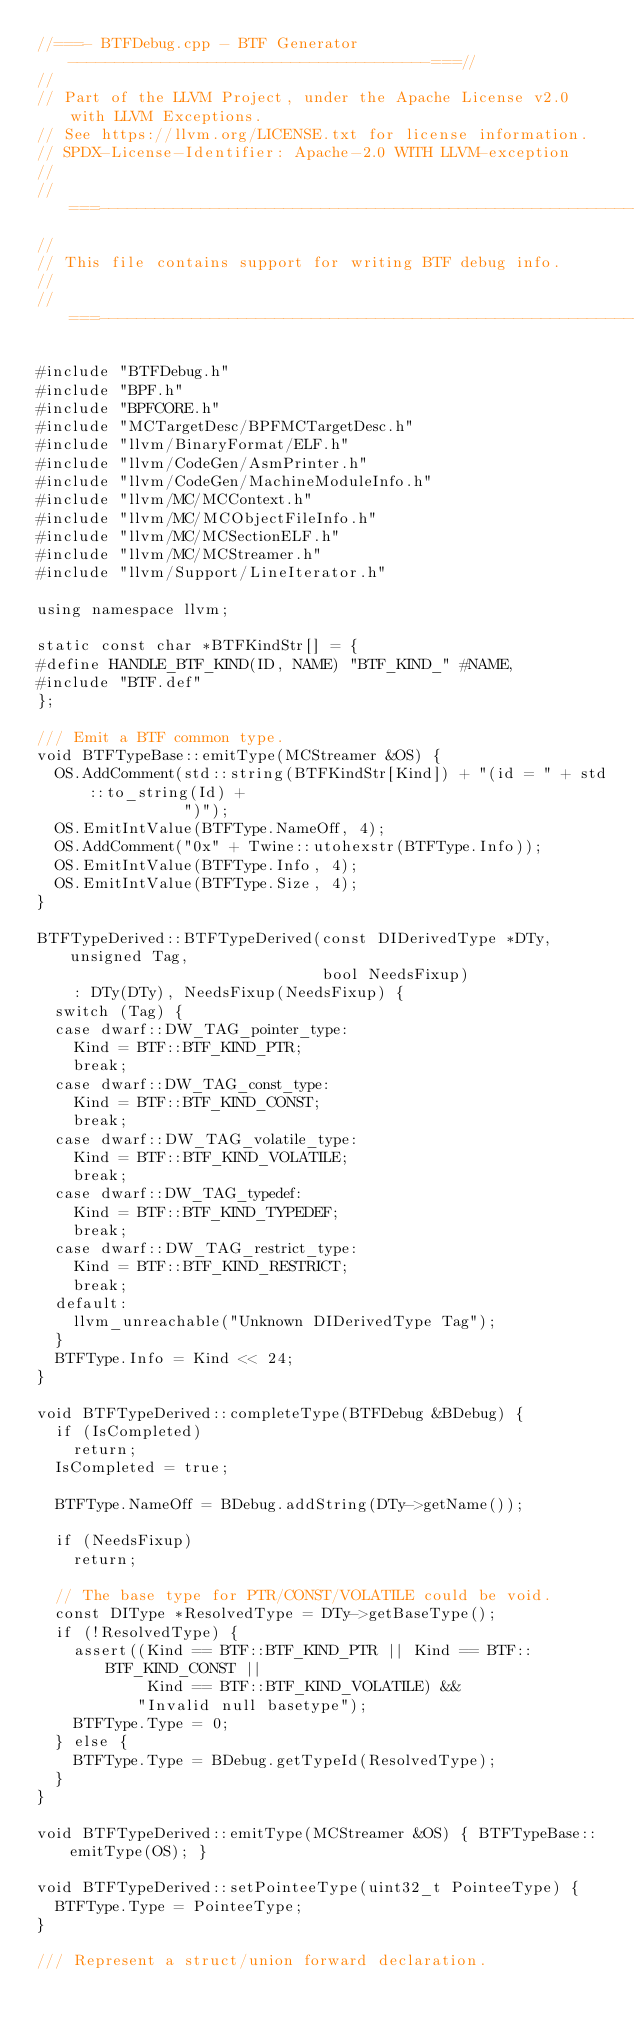<code> <loc_0><loc_0><loc_500><loc_500><_C++_>//===- BTFDebug.cpp - BTF Generator ---------------------------------------===//
//
// Part of the LLVM Project, under the Apache License v2.0 with LLVM Exceptions.
// See https://llvm.org/LICENSE.txt for license information.
// SPDX-License-Identifier: Apache-2.0 WITH LLVM-exception
//
//===----------------------------------------------------------------------===//
//
// This file contains support for writing BTF debug info.
//
//===----------------------------------------------------------------------===//

#include "BTFDebug.h"
#include "BPF.h"
#include "BPFCORE.h"
#include "MCTargetDesc/BPFMCTargetDesc.h"
#include "llvm/BinaryFormat/ELF.h"
#include "llvm/CodeGen/AsmPrinter.h"
#include "llvm/CodeGen/MachineModuleInfo.h"
#include "llvm/MC/MCContext.h"
#include "llvm/MC/MCObjectFileInfo.h"
#include "llvm/MC/MCSectionELF.h"
#include "llvm/MC/MCStreamer.h"
#include "llvm/Support/LineIterator.h"

using namespace llvm;

static const char *BTFKindStr[] = {
#define HANDLE_BTF_KIND(ID, NAME) "BTF_KIND_" #NAME,
#include "BTF.def"
};

/// Emit a BTF common type.
void BTFTypeBase::emitType(MCStreamer &OS) {
  OS.AddComment(std::string(BTFKindStr[Kind]) + "(id = " + std::to_string(Id) +
                ")");
  OS.EmitIntValue(BTFType.NameOff, 4);
  OS.AddComment("0x" + Twine::utohexstr(BTFType.Info));
  OS.EmitIntValue(BTFType.Info, 4);
  OS.EmitIntValue(BTFType.Size, 4);
}

BTFTypeDerived::BTFTypeDerived(const DIDerivedType *DTy, unsigned Tag,
                               bool NeedsFixup)
    : DTy(DTy), NeedsFixup(NeedsFixup) {
  switch (Tag) {
  case dwarf::DW_TAG_pointer_type:
    Kind = BTF::BTF_KIND_PTR;
    break;
  case dwarf::DW_TAG_const_type:
    Kind = BTF::BTF_KIND_CONST;
    break;
  case dwarf::DW_TAG_volatile_type:
    Kind = BTF::BTF_KIND_VOLATILE;
    break;
  case dwarf::DW_TAG_typedef:
    Kind = BTF::BTF_KIND_TYPEDEF;
    break;
  case dwarf::DW_TAG_restrict_type:
    Kind = BTF::BTF_KIND_RESTRICT;
    break;
  default:
    llvm_unreachable("Unknown DIDerivedType Tag");
  }
  BTFType.Info = Kind << 24;
}

void BTFTypeDerived::completeType(BTFDebug &BDebug) {
  if (IsCompleted)
    return;
  IsCompleted = true;

  BTFType.NameOff = BDebug.addString(DTy->getName());

  if (NeedsFixup)
    return;

  // The base type for PTR/CONST/VOLATILE could be void.
  const DIType *ResolvedType = DTy->getBaseType();
  if (!ResolvedType) {
    assert((Kind == BTF::BTF_KIND_PTR || Kind == BTF::BTF_KIND_CONST ||
            Kind == BTF::BTF_KIND_VOLATILE) &&
           "Invalid null basetype");
    BTFType.Type = 0;
  } else {
    BTFType.Type = BDebug.getTypeId(ResolvedType);
  }
}

void BTFTypeDerived::emitType(MCStreamer &OS) { BTFTypeBase::emitType(OS); }

void BTFTypeDerived::setPointeeType(uint32_t PointeeType) {
  BTFType.Type = PointeeType;
}

/// Represent a struct/union forward declaration.</code> 